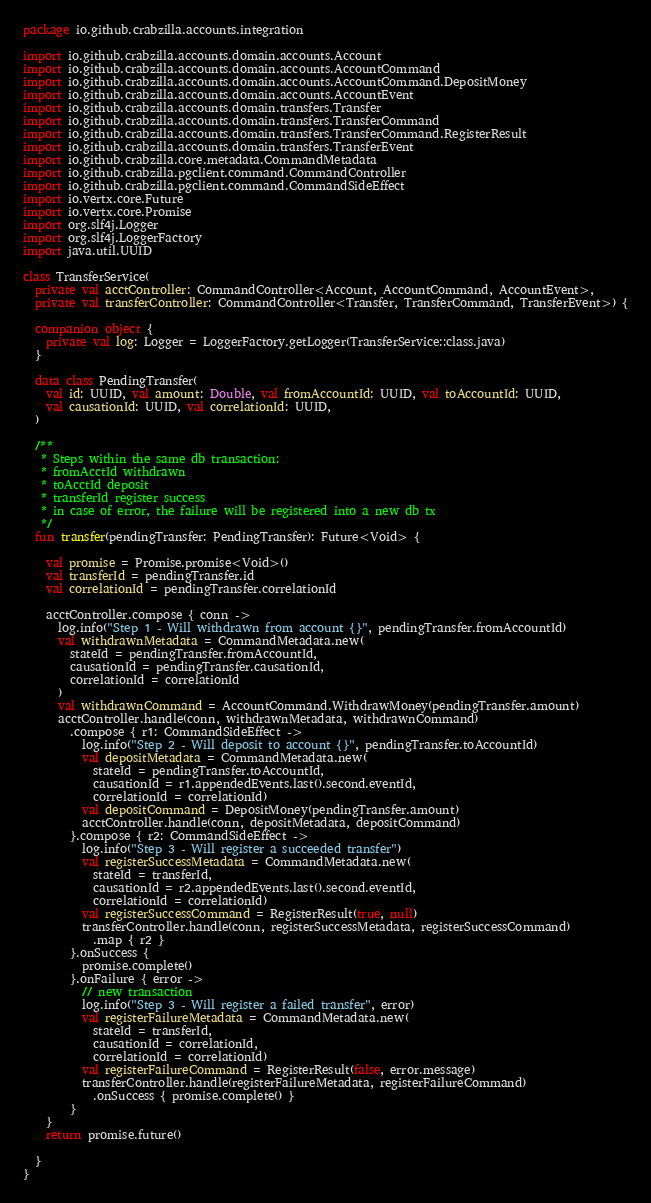Convert code to text. <code><loc_0><loc_0><loc_500><loc_500><_Kotlin_>package io.github.crabzilla.accounts.integration

import io.github.crabzilla.accounts.domain.accounts.Account
import io.github.crabzilla.accounts.domain.accounts.AccountCommand
import io.github.crabzilla.accounts.domain.accounts.AccountCommand.DepositMoney
import io.github.crabzilla.accounts.domain.accounts.AccountEvent
import io.github.crabzilla.accounts.domain.transfers.Transfer
import io.github.crabzilla.accounts.domain.transfers.TransferCommand
import io.github.crabzilla.accounts.domain.transfers.TransferCommand.RegisterResult
import io.github.crabzilla.accounts.domain.transfers.TransferEvent
import io.github.crabzilla.core.metadata.CommandMetadata
import io.github.crabzilla.pgclient.command.CommandController
import io.github.crabzilla.pgclient.command.CommandSideEffect
import io.vertx.core.Future
import io.vertx.core.Promise
import org.slf4j.Logger
import org.slf4j.LoggerFactory
import java.util.UUID

class TransferService(
  private val acctController: CommandController<Account, AccountCommand, AccountEvent>,
  private val transferController: CommandController<Transfer, TransferCommand, TransferEvent>) {
  
  companion object {
    private val log: Logger = LoggerFactory.getLogger(TransferService::class.java)
  }

  data class PendingTransfer(
    val id: UUID, val amount: Double, val fromAccountId: UUID, val toAccountId: UUID,
    val causationId: UUID, val correlationId: UUID,
  )

  /**
   * Steps within the same db transaction:
   * fromAcctId withdrawn
   * toAcctId deposit
   * transferId register success
   * in case of error, the failure will be registered into a new db tx
   */
  fun transfer(pendingTransfer: PendingTransfer): Future<Void> {

    val promise = Promise.promise<Void>()
    val transferId = pendingTransfer.id
    val correlationId = pendingTransfer.correlationId

    acctController.compose { conn ->
      log.info("Step 1 - Will withdrawn from account {}", pendingTransfer.fromAccountId)
      val withdrawnMetadata = CommandMetadata.new(
        stateId = pendingTransfer.fromAccountId,
        causationId = pendingTransfer.causationId,
        correlationId = correlationId
      )
      val withdrawnCommand = AccountCommand.WithdrawMoney(pendingTransfer.amount)
      acctController.handle(conn, withdrawnMetadata, withdrawnCommand)
        .compose { r1: CommandSideEffect ->
          log.info("Step 2 - Will deposit to account {}", pendingTransfer.toAccountId)
          val depositMetadata = CommandMetadata.new(
            stateId = pendingTransfer.toAccountId,
            causationId = r1.appendedEvents.last().second.eventId,
            correlationId = correlationId)
          val depositCommand = DepositMoney(pendingTransfer.amount)
          acctController.handle(conn, depositMetadata, depositCommand)
        }.compose { r2: CommandSideEffect ->
          log.info("Step 3 - Will register a succeeded transfer")
          val registerSuccessMetadata = CommandMetadata.new(
            stateId = transferId,
            causationId = r2.appendedEvents.last().second.eventId,
            correlationId = correlationId)
          val registerSuccessCommand = RegisterResult(true, null)
          transferController.handle(conn, registerSuccessMetadata, registerSuccessCommand)
            .map { r2 }
        }.onSuccess {
          promise.complete()
        }.onFailure { error ->
          // new transaction
          log.info("Step 3 - Will register a failed transfer", error)
          val registerFailureMetadata = CommandMetadata.new(
            stateId = transferId,
            causationId = correlationId,
            correlationId = correlationId)
          val registerFailureCommand = RegisterResult(false, error.message)
          transferController.handle(registerFailureMetadata, registerFailureCommand)
            .onSuccess { promise.complete() }
        }
    }
    return promise.future()

  }
}</code> 